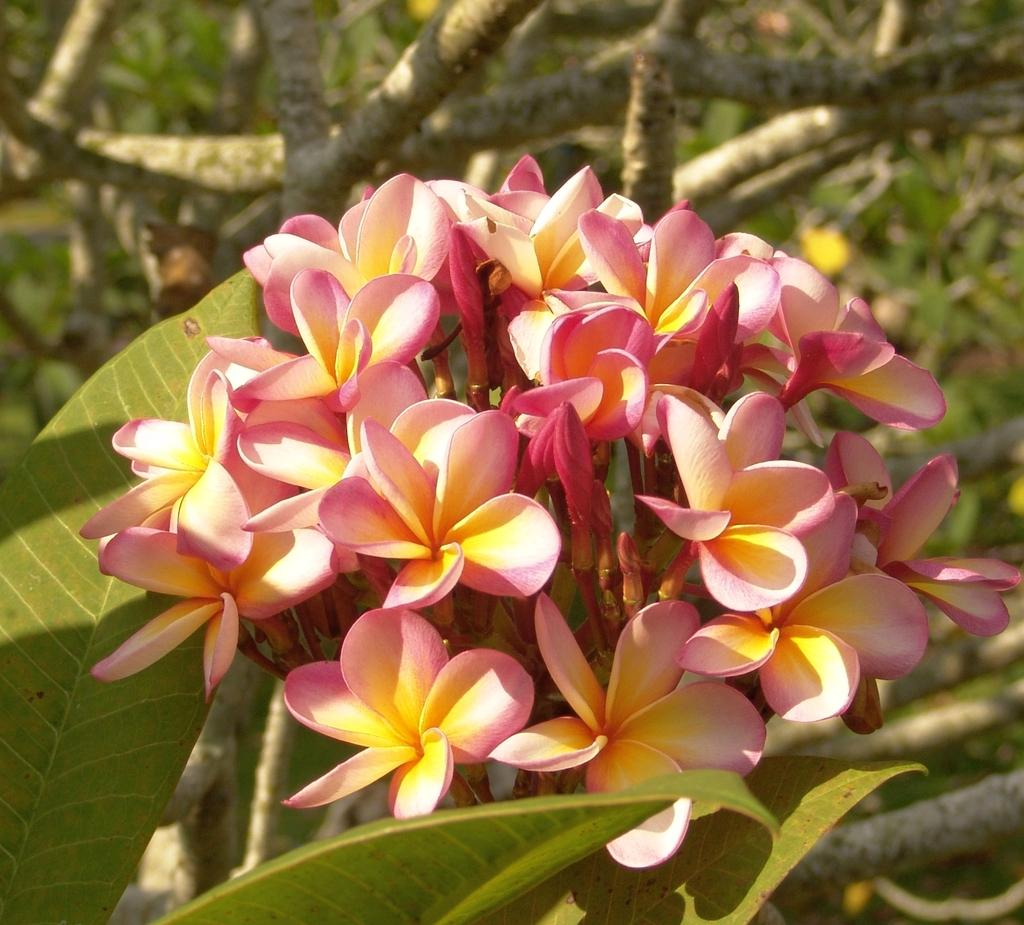What type of living organism is present in the image? There is a plant in the image. What features can be observed on the plant? The plant has flowers and leaves. What type of cushion is used to support the plant in the image? There is no cushion present in the image; the plant is not supported by any cushion. 